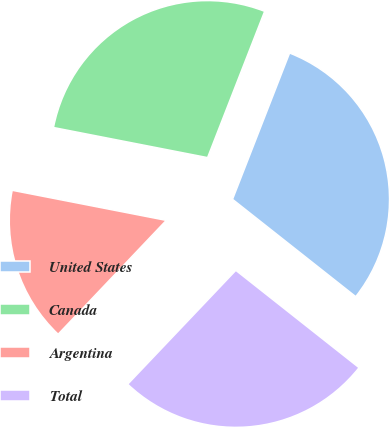Convert chart to OTSL. <chart><loc_0><loc_0><loc_500><loc_500><pie_chart><fcel>United States<fcel>Canada<fcel>Argentina<fcel>Total<nl><fcel>29.72%<fcel>27.85%<fcel>15.98%<fcel>26.45%<nl></chart> 